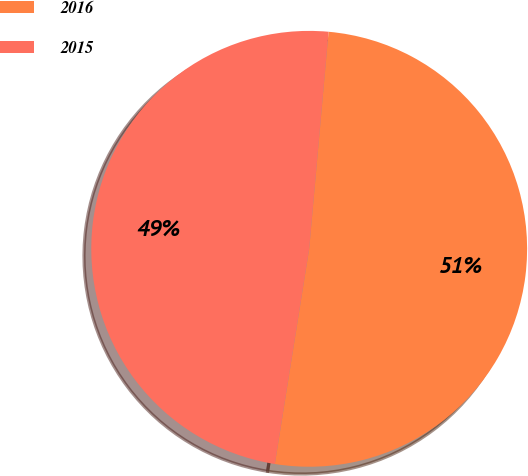Convert chart. <chart><loc_0><loc_0><loc_500><loc_500><pie_chart><fcel>2016<fcel>2015<nl><fcel>51.1%<fcel>48.9%<nl></chart> 